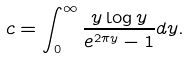<formula> <loc_0><loc_0><loc_500><loc_500>c = \int _ { 0 } ^ { \infty } \frac { y \log y } { e ^ { 2 \pi y } - 1 } d y .</formula> 